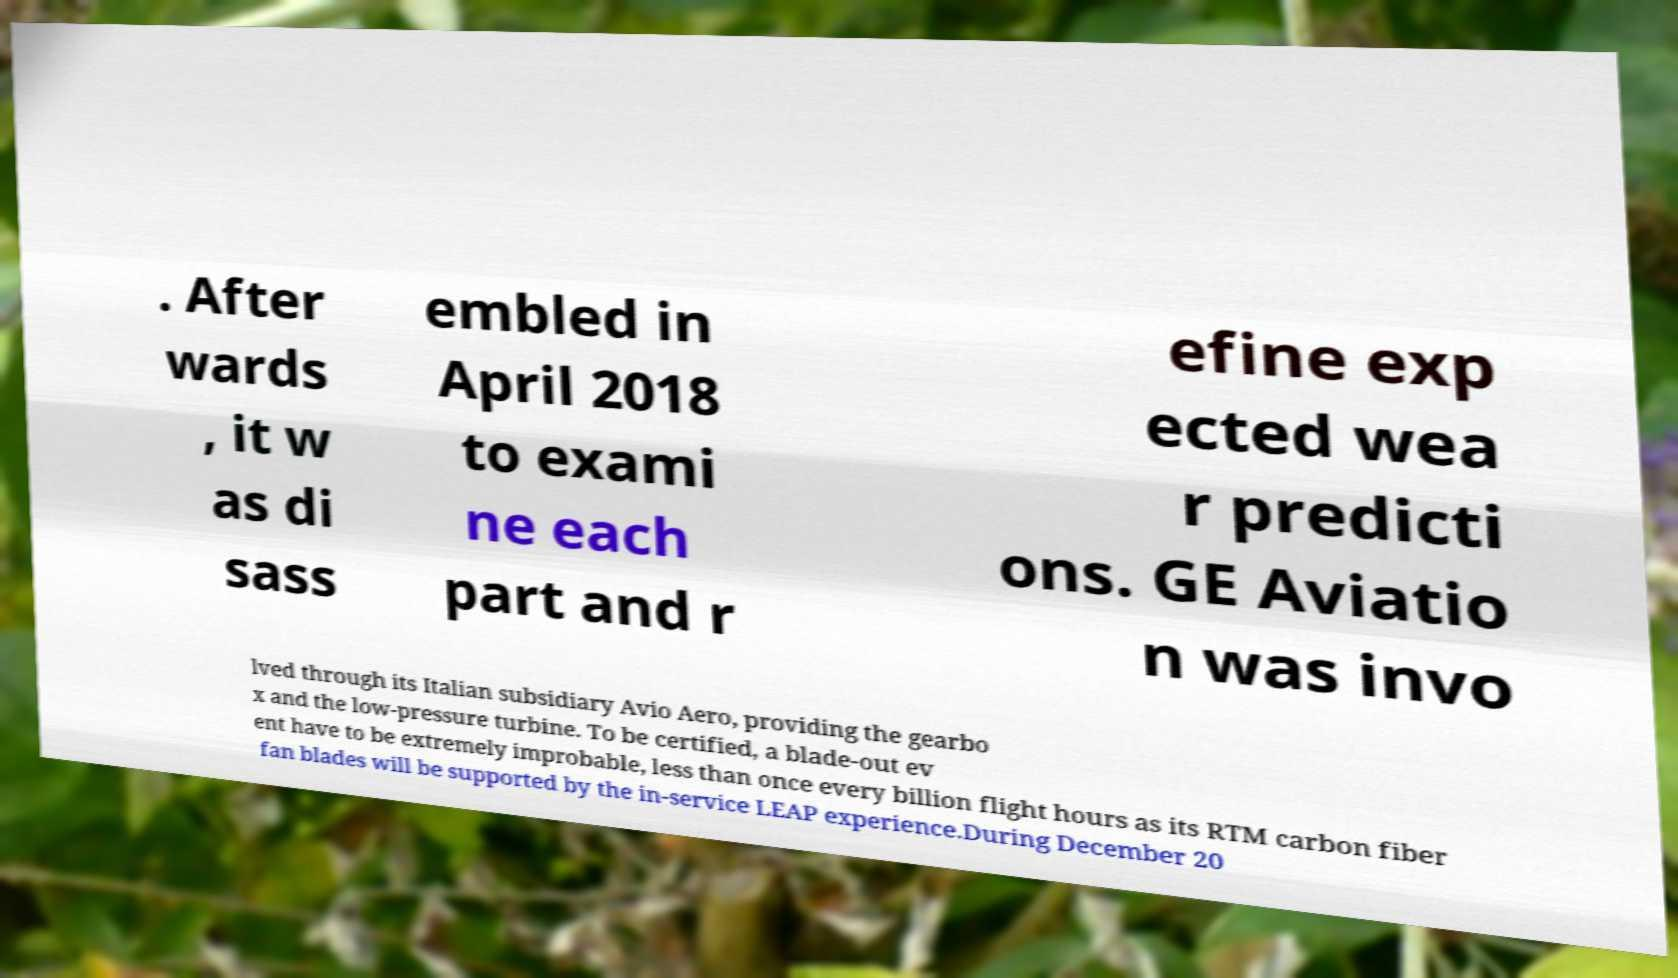For documentation purposes, I need the text within this image transcribed. Could you provide that? . After wards , it w as di sass embled in April 2018 to exami ne each part and r efine exp ected wea r predicti ons. GE Aviatio n was invo lved through its Italian subsidiary Avio Aero, providing the gearbo x and the low-pressure turbine. To be certified, a blade-out ev ent have to be extremely improbable, less than once every billion flight hours as its RTM carbon fiber fan blades will be supported by the in-service LEAP experience.During December 20 